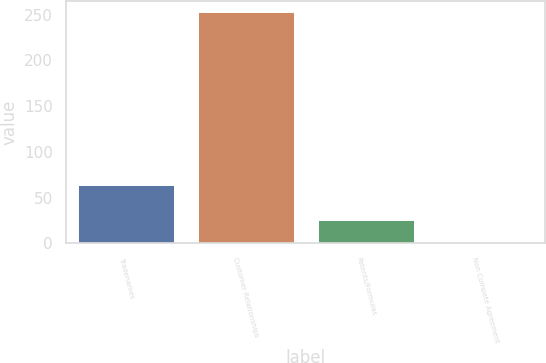Convert chart. <chart><loc_0><loc_0><loc_500><loc_500><bar_chart><fcel>Tradenames<fcel>Customer Relationships<fcel>Patents/Formulas<fcel>Non Compete Agreement<nl><fcel>64<fcel>252.7<fcel>25.36<fcel>0.1<nl></chart> 